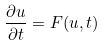Convert formula to latex. <formula><loc_0><loc_0><loc_500><loc_500>\frac { \partial u } { \partial t } = F ( u , t )</formula> 